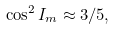Convert formula to latex. <formula><loc_0><loc_0><loc_500><loc_500>\cos ^ { 2 } I _ { m } \approx 3 / 5 ,</formula> 